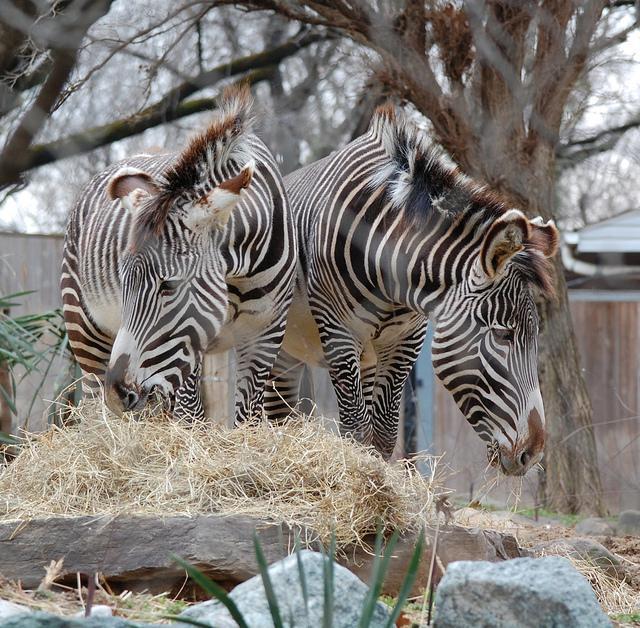How many zebras are there?
Give a very brief answer. 2. How many zebras has there head lowered?
Give a very brief answer. 2. How many zebras can you see?
Give a very brief answer. 2. 